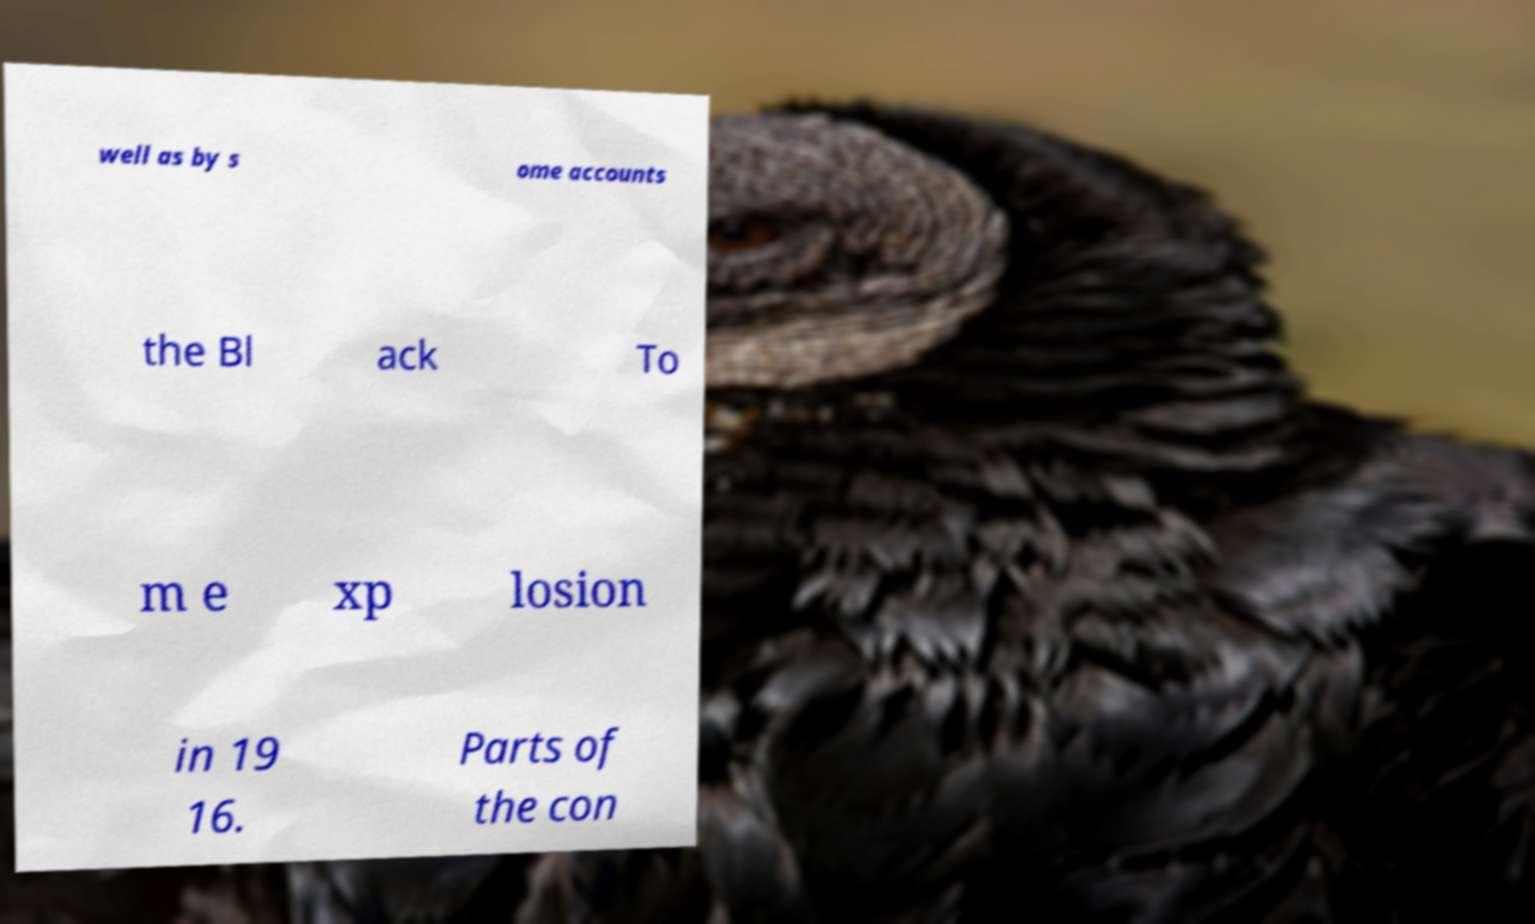Could you extract and type out the text from this image? well as by s ome accounts the Bl ack To m e xp losion in 19 16. Parts of the con 